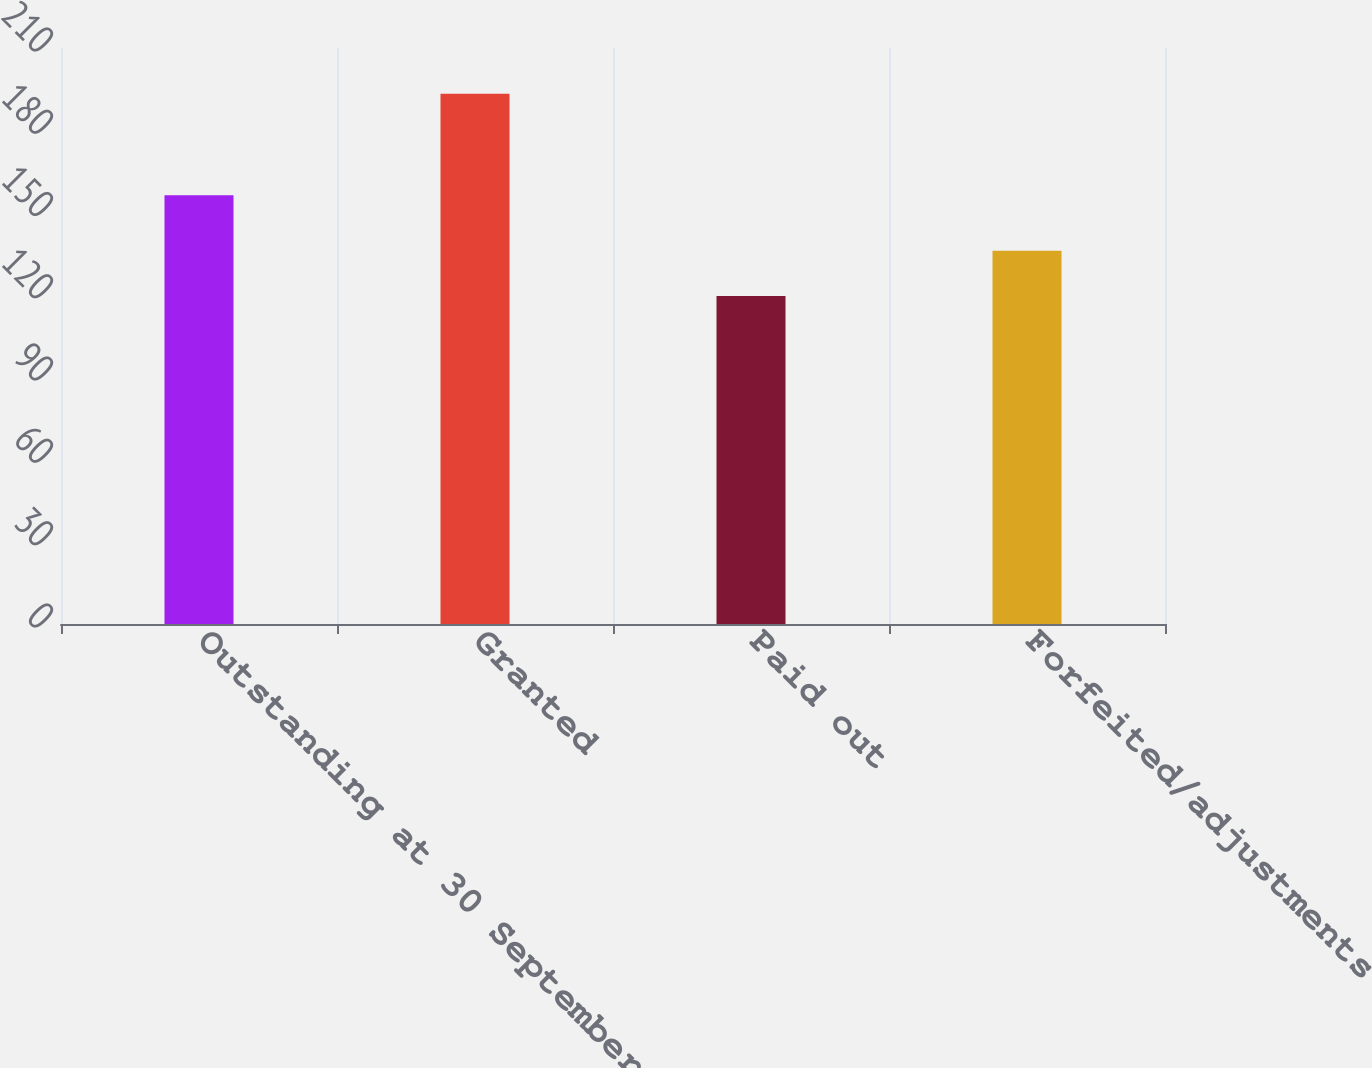<chart> <loc_0><loc_0><loc_500><loc_500><bar_chart><fcel>Outstanding at 30 September<fcel>Granted<fcel>Paid out<fcel>Forfeited/adjustments<nl><fcel>156.31<fcel>193.29<fcel>119.59<fcel>136.11<nl></chart> 